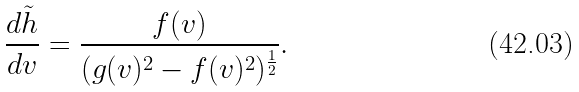<formula> <loc_0><loc_0><loc_500><loc_500>\frac { d \tilde { h } } { d v } = \frac { f ( v ) } { ( g ( v ) ^ { 2 } - f ( v ) ^ { 2 } ) ^ { \frac { 1 } { 2 } } } .</formula> 